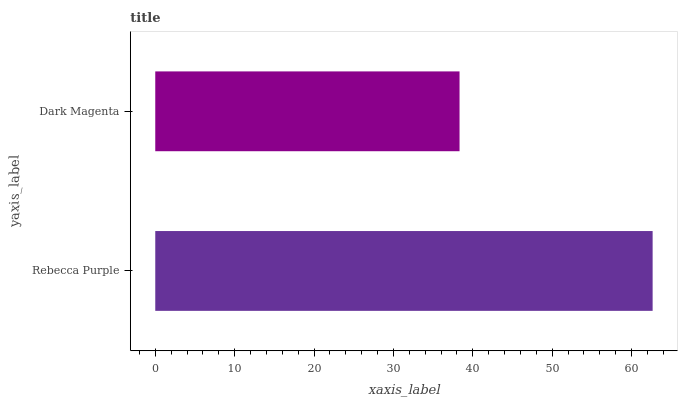Is Dark Magenta the minimum?
Answer yes or no. Yes. Is Rebecca Purple the maximum?
Answer yes or no. Yes. Is Dark Magenta the maximum?
Answer yes or no. No. Is Rebecca Purple greater than Dark Magenta?
Answer yes or no. Yes. Is Dark Magenta less than Rebecca Purple?
Answer yes or no. Yes. Is Dark Magenta greater than Rebecca Purple?
Answer yes or no. No. Is Rebecca Purple less than Dark Magenta?
Answer yes or no. No. Is Rebecca Purple the high median?
Answer yes or no. Yes. Is Dark Magenta the low median?
Answer yes or no. Yes. Is Dark Magenta the high median?
Answer yes or no. No. Is Rebecca Purple the low median?
Answer yes or no. No. 